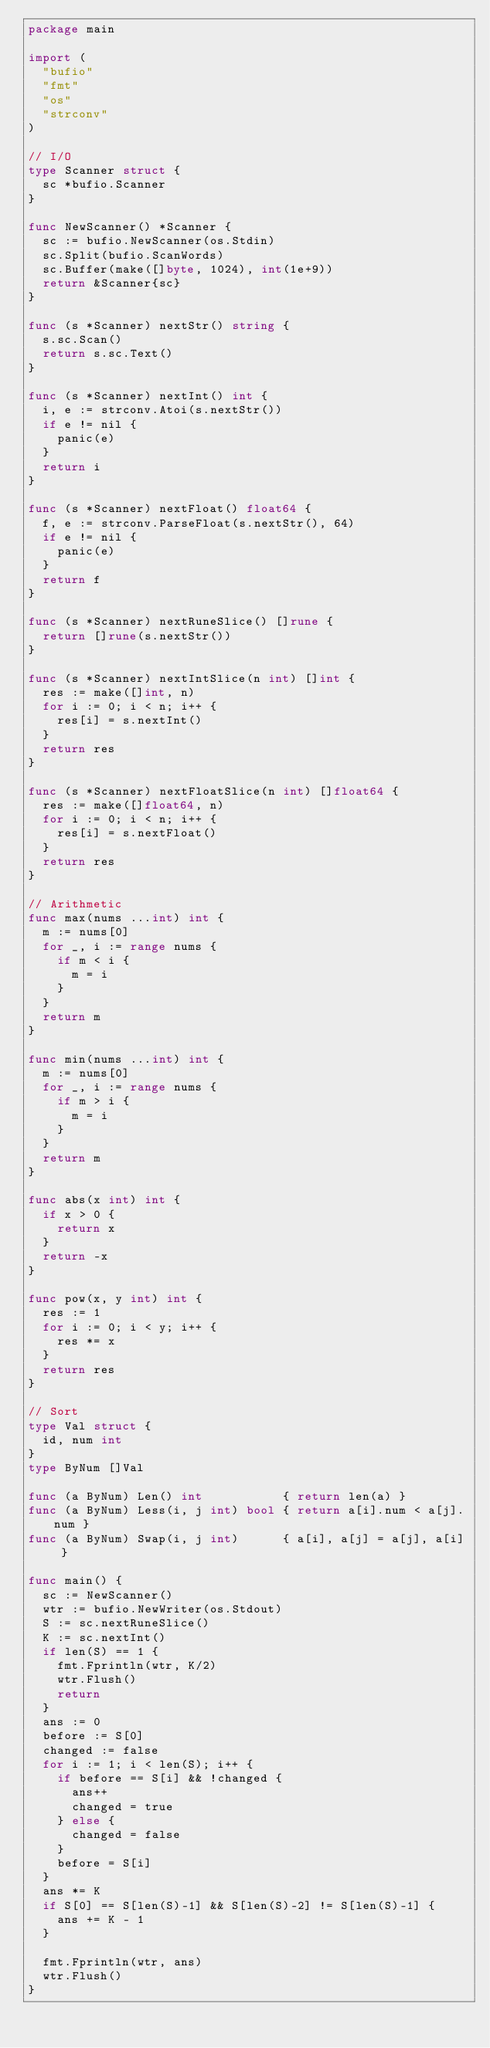Convert code to text. <code><loc_0><loc_0><loc_500><loc_500><_Go_>package main

import (
	"bufio"
	"fmt"
	"os"
	"strconv"
)

// I/O
type Scanner struct {
	sc *bufio.Scanner
}

func NewScanner() *Scanner {
	sc := bufio.NewScanner(os.Stdin)
	sc.Split(bufio.ScanWords)
	sc.Buffer(make([]byte, 1024), int(1e+9))
	return &Scanner{sc}
}

func (s *Scanner) nextStr() string {
	s.sc.Scan()
	return s.sc.Text()
}

func (s *Scanner) nextInt() int {
	i, e := strconv.Atoi(s.nextStr())
	if e != nil {
		panic(e)
	}
	return i
}

func (s *Scanner) nextFloat() float64 {
	f, e := strconv.ParseFloat(s.nextStr(), 64)
	if e != nil {
		panic(e)
	}
	return f
}

func (s *Scanner) nextRuneSlice() []rune {
	return []rune(s.nextStr())
}

func (s *Scanner) nextIntSlice(n int) []int {
	res := make([]int, n)
	for i := 0; i < n; i++ {
		res[i] = s.nextInt()
	}
	return res
}

func (s *Scanner) nextFloatSlice(n int) []float64 {
	res := make([]float64, n)
	for i := 0; i < n; i++ {
		res[i] = s.nextFloat()
	}
	return res
}

// Arithmetic
func max(nums ...int) int {
	m := nums[0]
	for _, i := range nums {
		if m < i {
			m = i
		}
	}
	return m
}

func min(nums ...int) int {
	m := nums[0]
	for _, i := range nums {
		if m > i {
			m = i
		}
	}
	return m
}

func abs(x int) int {
	if x > 0 {
		return x
	}
	return -x
}

func pow(x, y int) int {
	res := 1
	for i := 0; i < y; i++ {
		res *= x
	}
	return res
}

// Sort
type Val struct {
	id, num int
}
type ByNum []Val

func (a ByNum) Len() int           { return len(a) }
func (a ByNum) Less(i, j int) bool { return a[i].num < a[j].num }
func (a ByNum) Swap(i, j int)      { a[i], a[j] = a[j], a[i] }

func main() {
	sc := NewScanner()
	wtr := bufio.NewWriter(os.Stdout)
	S := sc.nextRuneSlice()
	K := sc.nextInt()
	if len(S) == 1 {
		fmt.Fprintln(wtr, K/2)
		wtr.Flush()
		return
	}
	ans := 0
	before := S[0]
	changed := false
	for i := 1; i < len(S); i++ {
		if before == S[i] && !changed {
			ans++
			changed = true
		} else {
			changed = false
		}
		before = S[i]
	}
	ans *= K
	if S[0] == S[len(S)-1] && S[len(S)-2] != S[len(S)-1] {
		ans += K - 1
	}

	fmt.Fprintln(wtr, ans)
	wtr.Flush()
}
</code> 